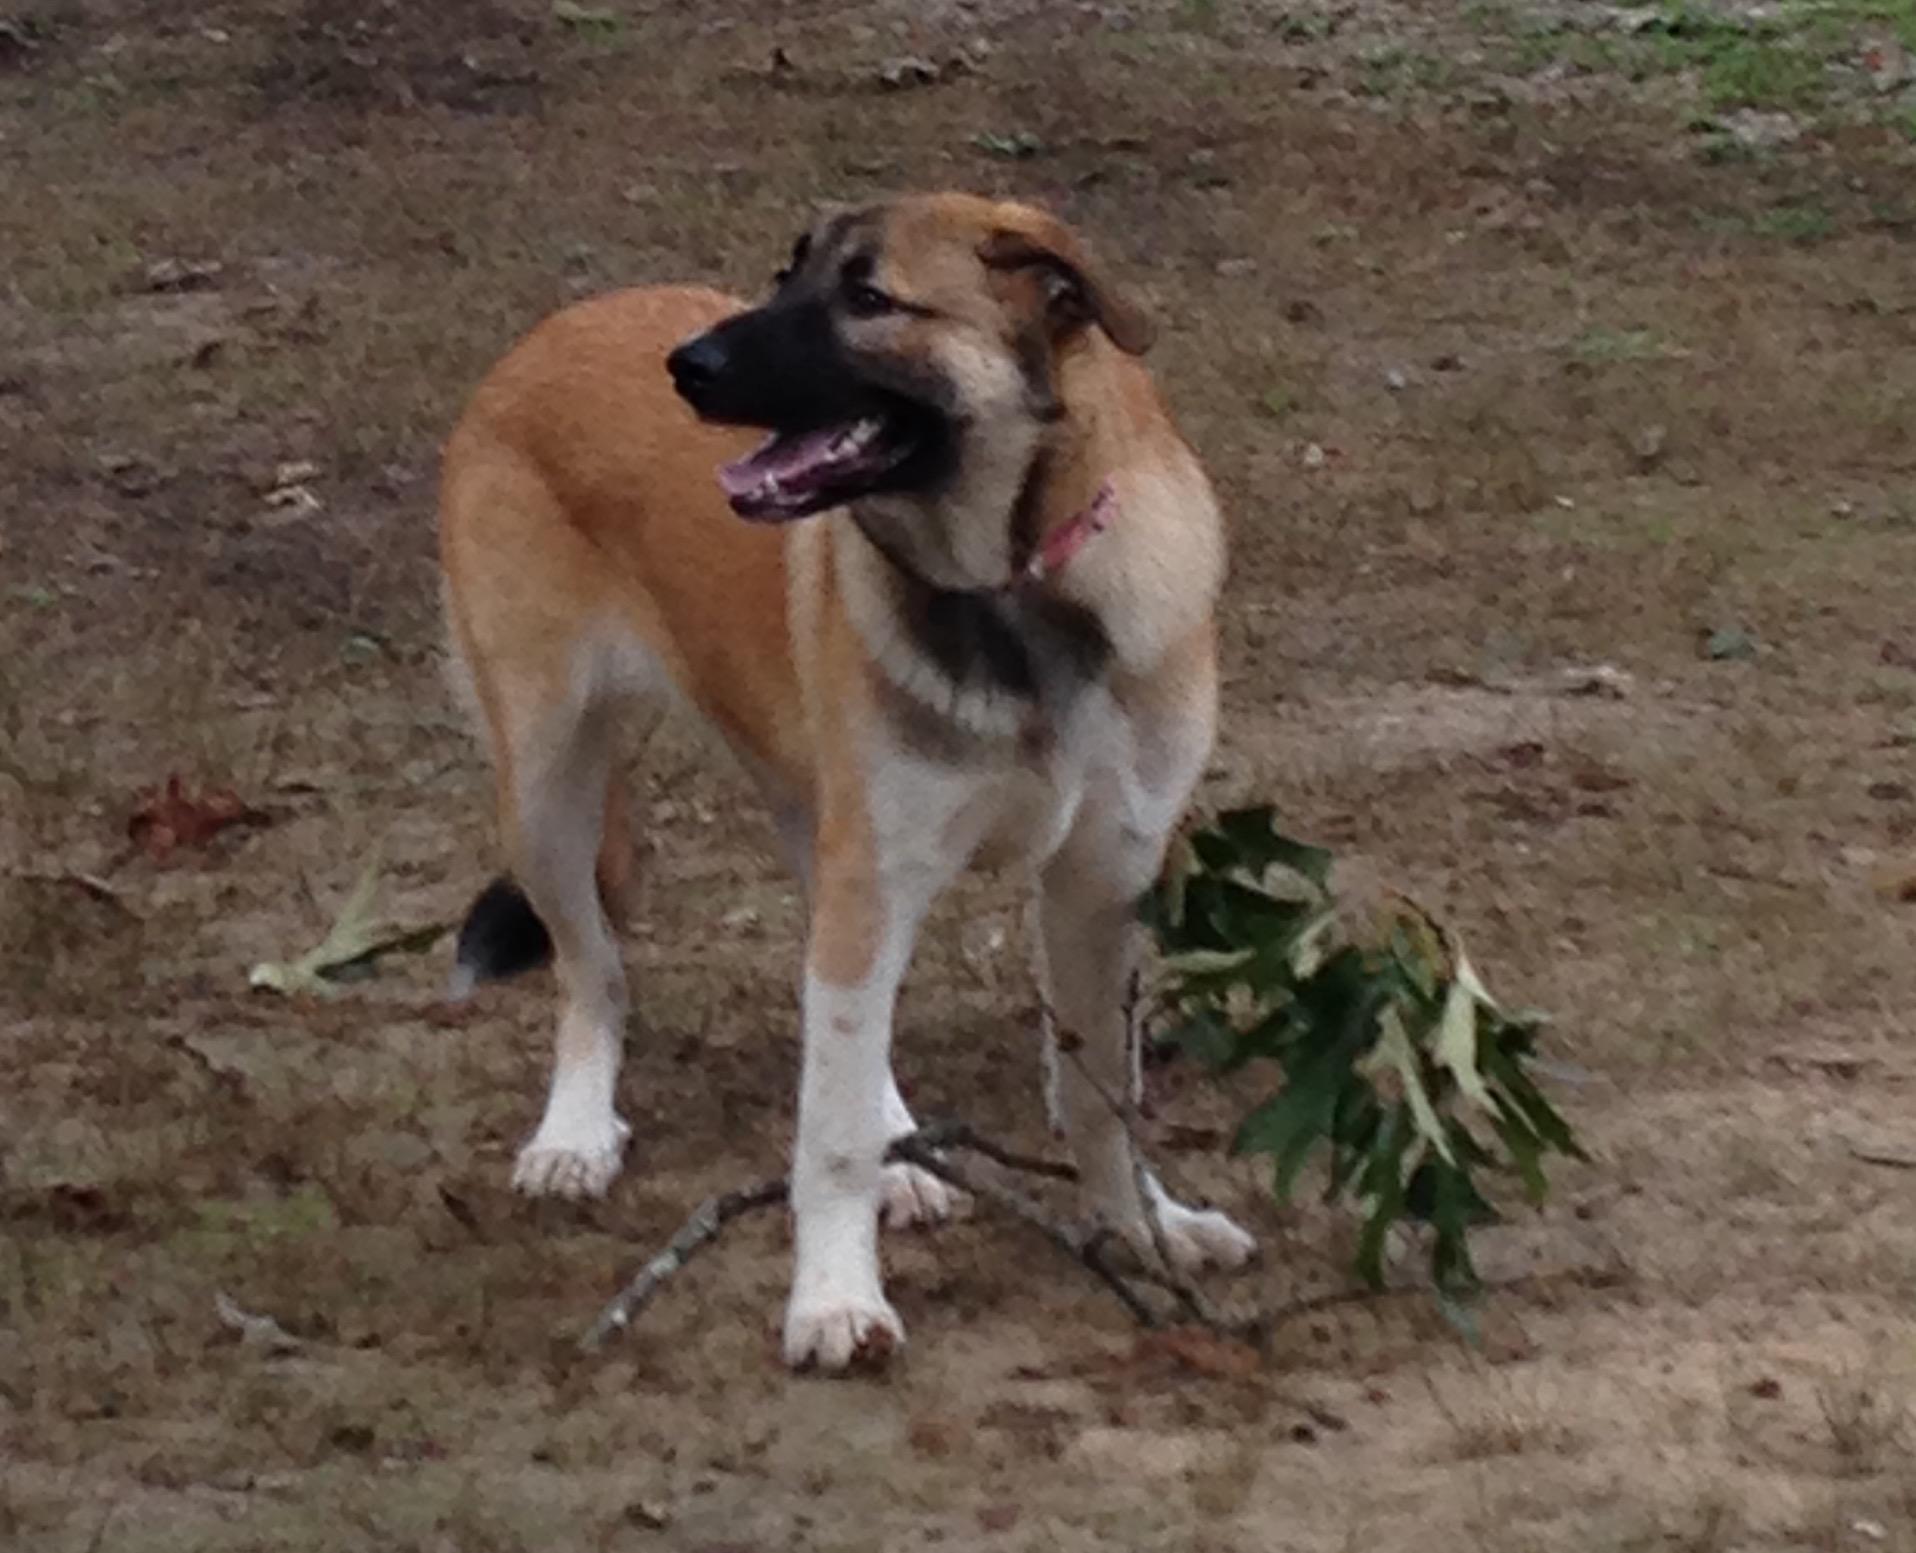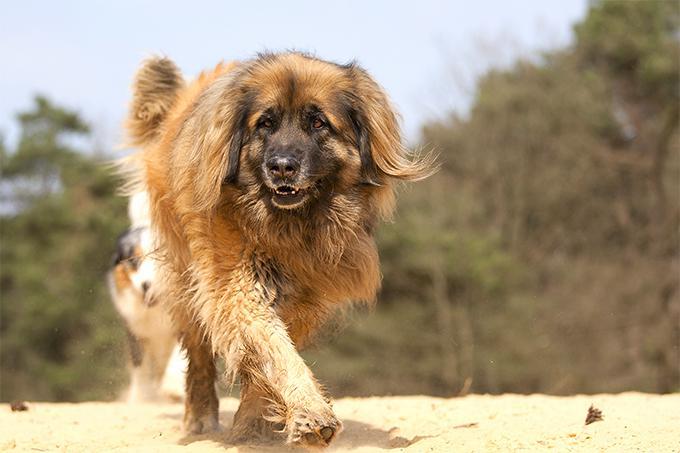The first image is the image on the left, the second image is the image on the right. For the images shown, is this caption "One image shows a dog walking toward the camera." true? Answer yes or no. Yes. The first image is the image on the left, the second image is the image on the right. Analyze the images presented: Is the assertion "A puppy is laying in the grass." valid? Answer yes or no. No. 